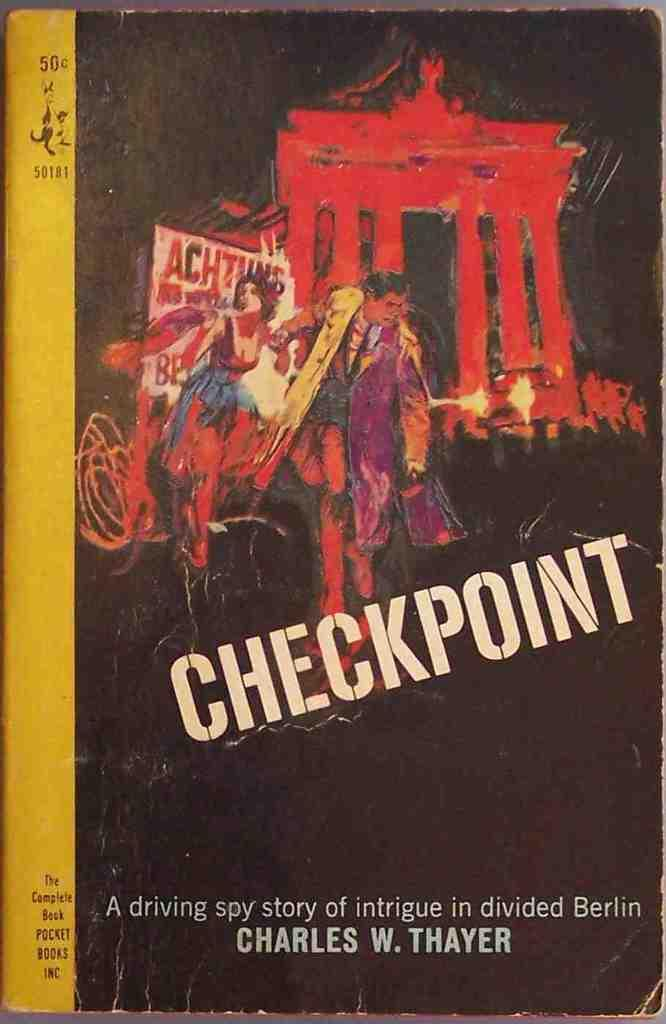Provide a one-sentence caption for the provided image. A paperback book from years past promises a spy story full of intrigue. 